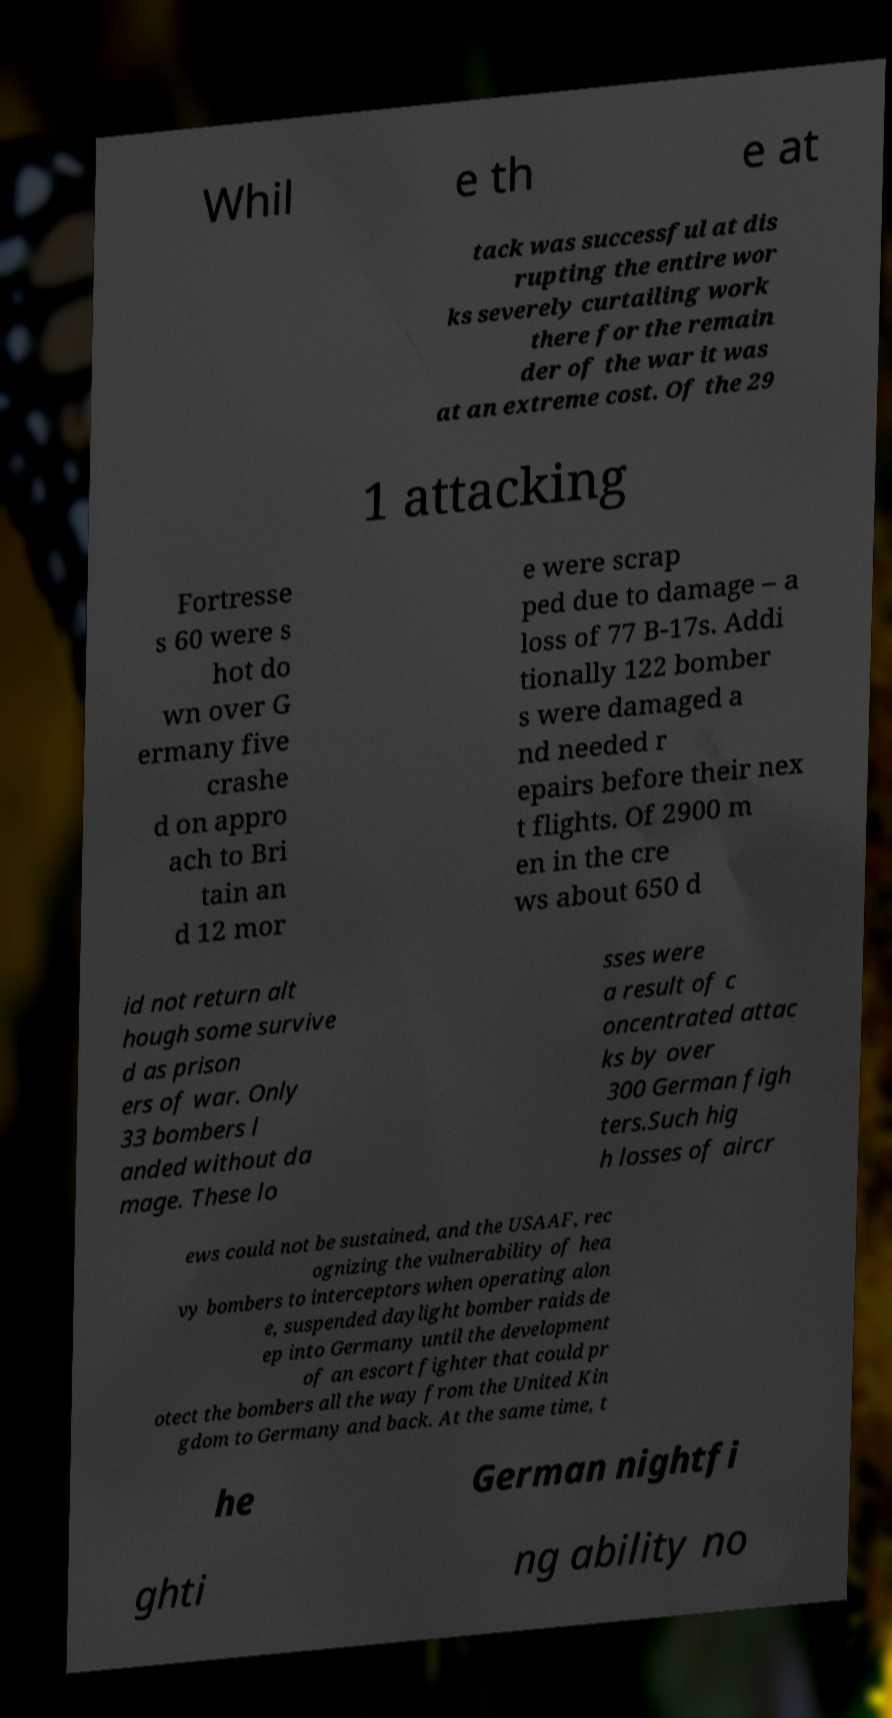Please identify and transcribe the text found in this image. Whil e th e at tack was successful at dis rupting the entire wor ks severely curtailing work there for the remain der of the war it was at an extreme cost. Of the 29 1 attacking Fortresse s 60 were s hot do wn over G ermany five crashe d on appro ach to Bri tain an d 12 mor e were scrap ped due to damage – a loss of 77 B-17s. Addi tionally 122 bomber s were damaged a nd needed r epairs before their nex t flights. Of 2900 m en in the cre ws about 650 d id not return alt hough some survive d as prison ers of war. Only 33 bombers l anded without da mage. These lo sses were a result of c oncentrated attac ks by over 300 German figh ters.Such hig h losses of aircr ews could not be sustained, and the USAAF, rec ognizing the vulnerability of hea vy bombers to interceptors when operating alon e, suspended daylight bomber raids de ep into Germany until the development of an escort fighter that could pr otect the bombers all the way from the United Kin gdom to Germany and back. At the same time, t he German nightfi ghti ng ability no 